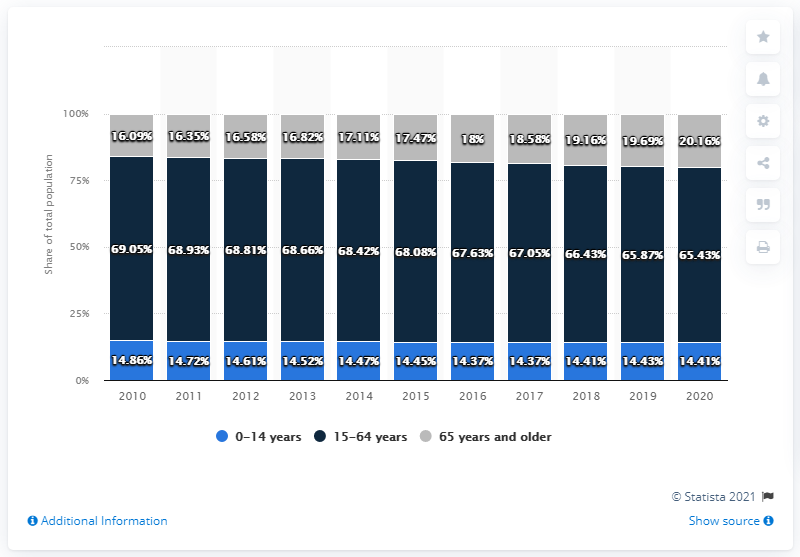Mention a couple of crucial points in this snapshot. The percentage value for 2015 in the 15-64 years category was 68.08%. The sum of 2020, excluding the value of the dark blue bar, is 34.57. 